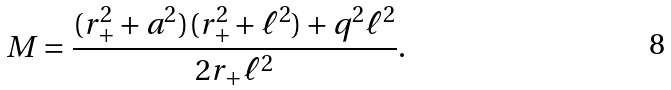Convert formula to latex. <formula><loc_0><loc_0><loc_500><loc_500>M = \frac { ( r _ { + } ^ { 2 } + a ^ { 2 } ) ( r _ { + } ^ { 2 } + \ell ^ { 2 } ) + q ^ { 2 } \ell ^ { 2 } } { 2 r _ { + } \ell ^ { 2 } } .</formula> 